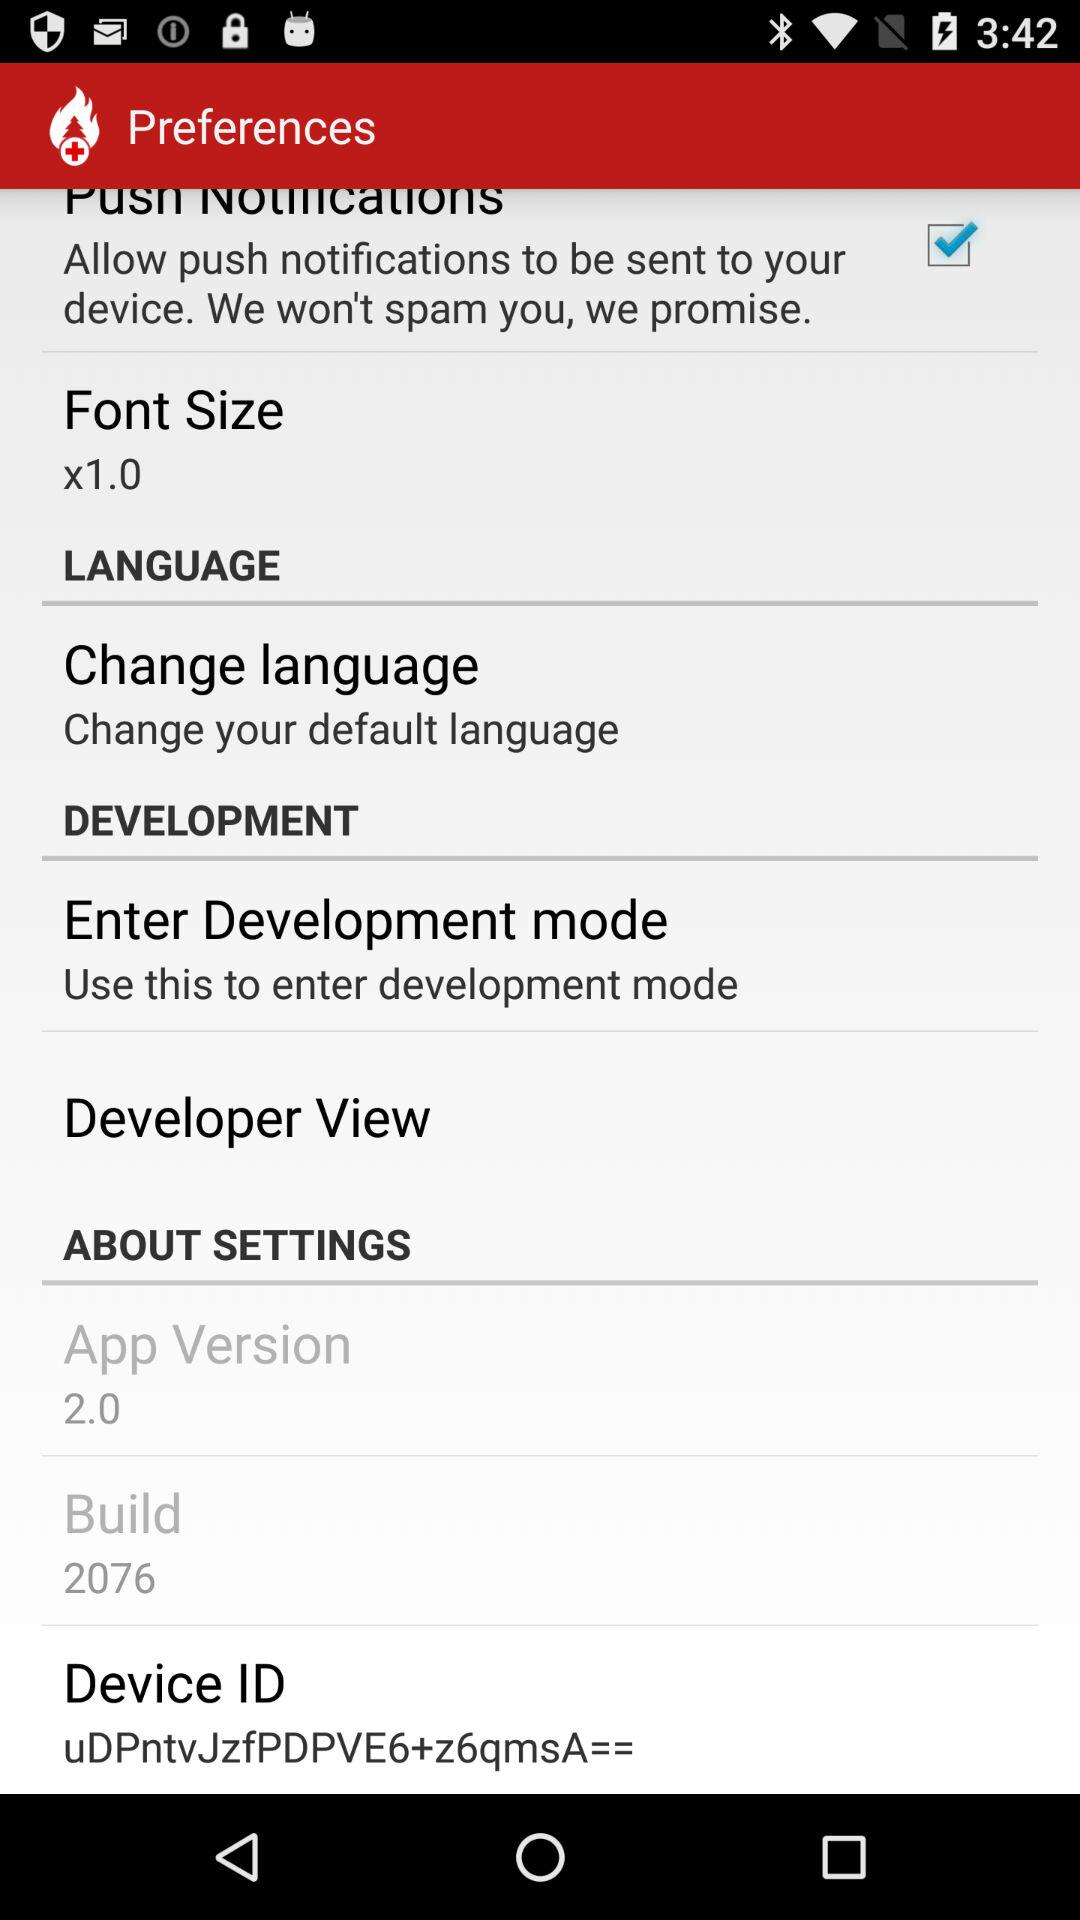What is the device ID? The device ID is "uDPntvJzfPDPVE6+z6qmsA==". 